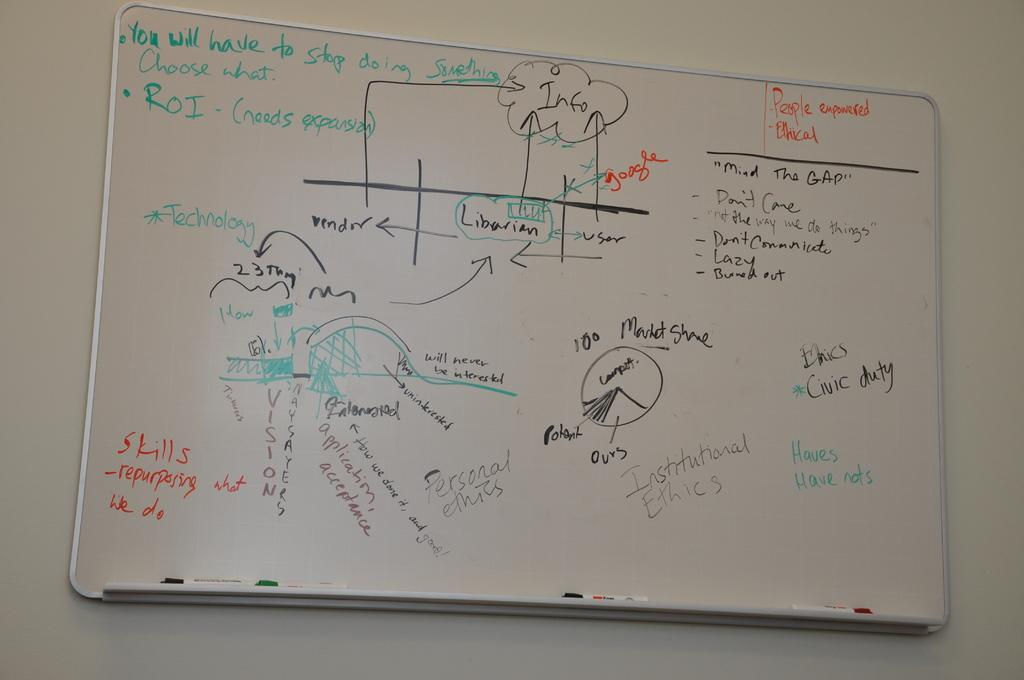<image>
Share a concise interpretation of the image provided. A white board on a wall as the word people on it. 